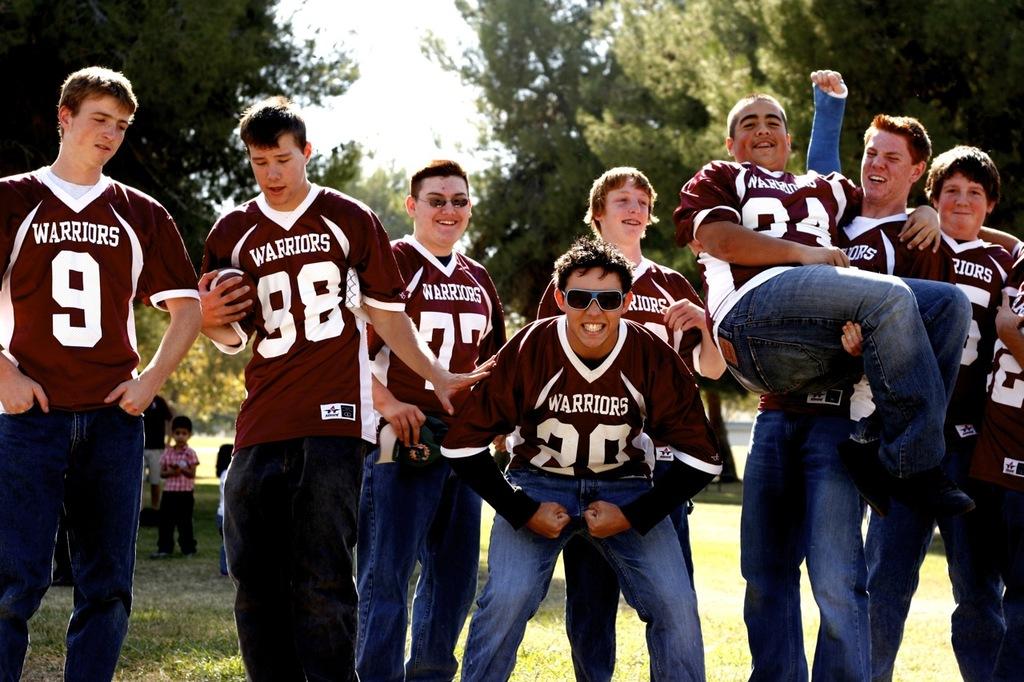What is their team name?
Give a very brief answer. Warriors. What is the player number of the person on the furthest left?
Offer a terse response. 9. 